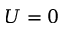Convert formula to latex. <formula><loc_0><loc_0><loc_500><loc_500>U = 0</formula> 